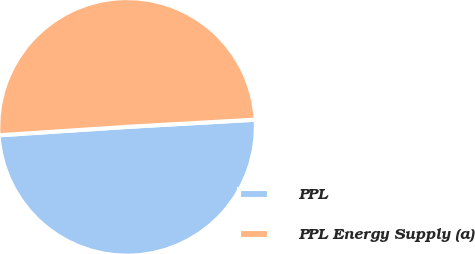Convert chart. <chart><loc_0><loc_0><loc_500><loc_500><pie_chart><fcel>PPL<fcel>PPL Energy Supply (a)<nl><fcel>49.85%<fcel>50.15%<nl></chart> 